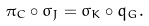<formula> <loc_0><loc_0><loc_500><loc_500>\pi _ { C } \circ \sigma _ { J } = \sigma _ { K } \circ q _ { G } .</formula> 